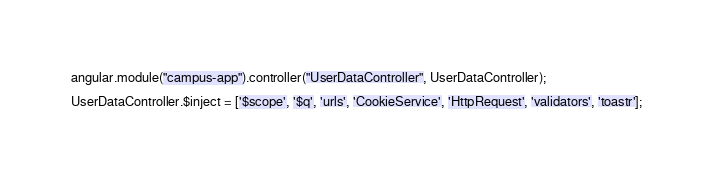Convert code to text. <code><loc_0><loc_0><loc_500><loc_500><_JavaScript_>angular.module("campus-app").controller("UserDataController", UserDataController);

UserDataController.$inject = ['$scope', '$q', 'urls', 'CookieService', 'HttpRequest', 'validators', 'toastr'];
</code> 